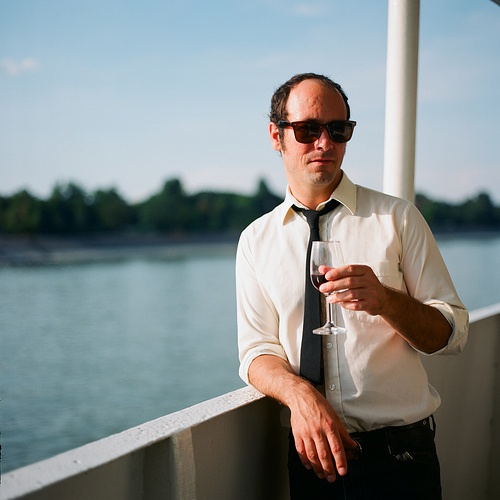Describe the objects in this image and their specific colors. I can see people in lightblue, black, lightgray, gray, and maroon tones, tie in lightblue, black, gray, and darkgray tones, and wine glass in lightblue, lightgray, darkgray, black, and tan tones in this image. 